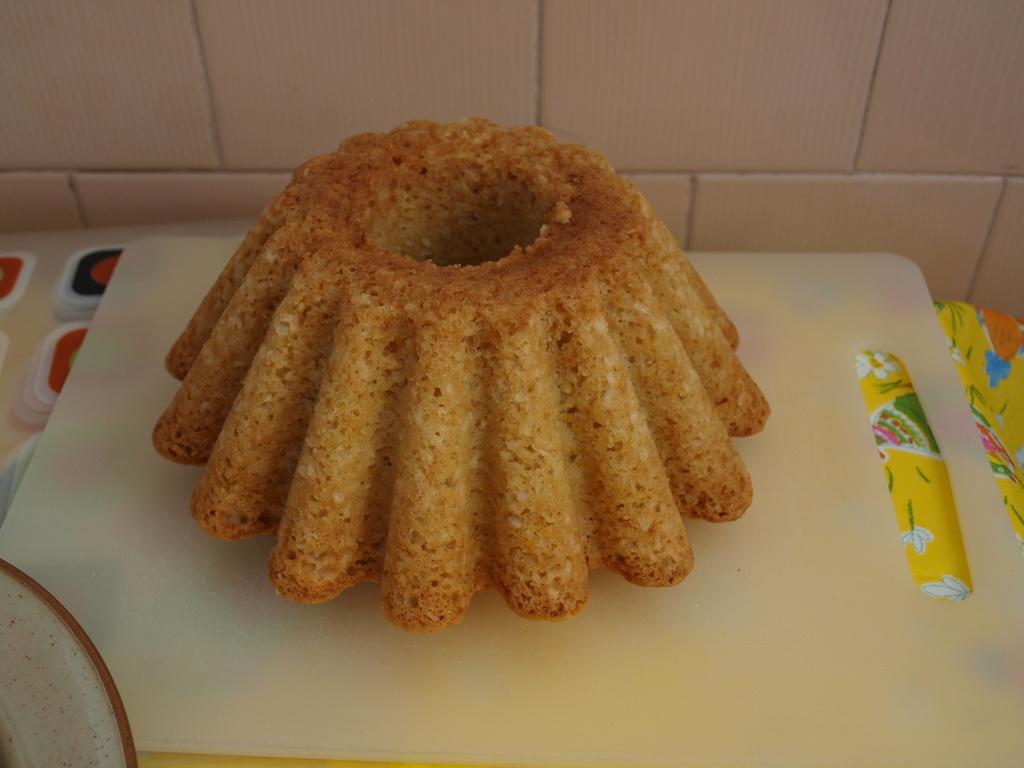Could you give a brief overview of what you see in this image? In this image I can see the food which is in brown color and the food is on the white color board. Background the wall is in white color. 